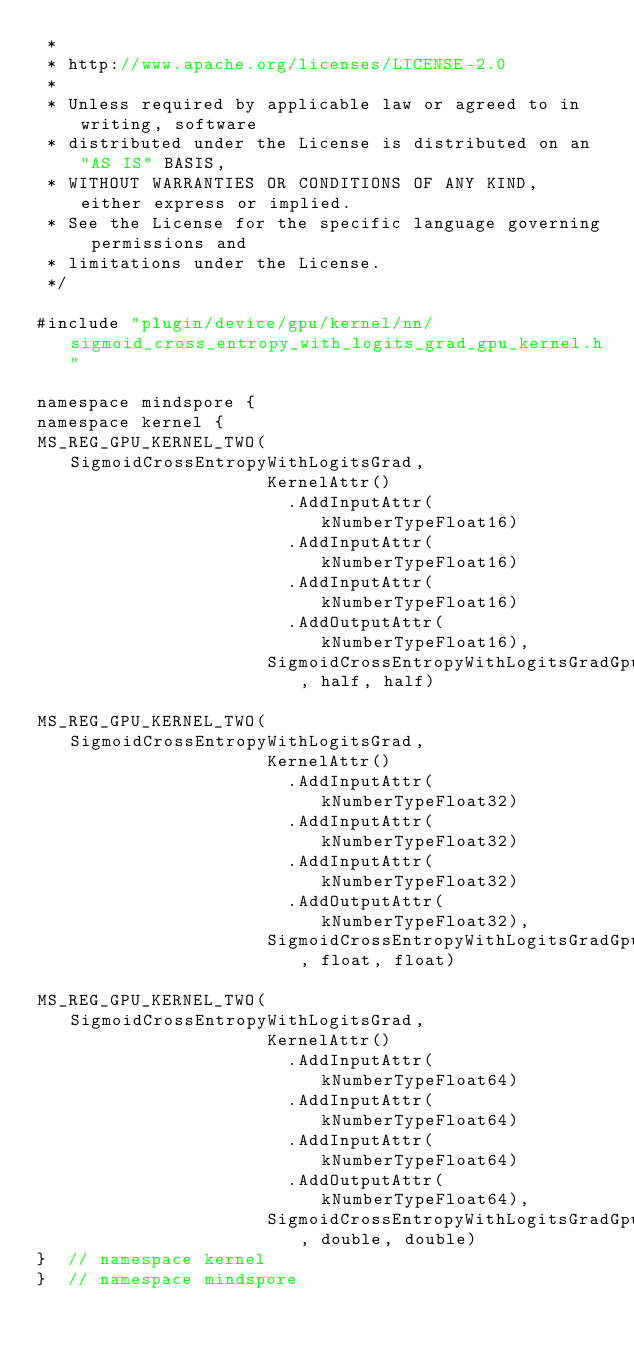<code> <loc_0><loc_0><loc_500><loc_500><_C++_> *
 * http://www.apache.org/licenses/LICENSE-2.0
 *
 * Unless required by applicable law or agreed to in writing, software
 * distributed under the License is distributed on an "AS IS" BASIS,
 * WITHOUT WARRANTIES OR CONDITIONS OF ANY KIND, either express or implied.
 * See the License for the specific language governing permissions and
 * limitations under the License.
 */

#include "plugin/device/gpu/kernel/nn/sigmoid_cross_entropy_with_logits_grad_gpu_kernel.h"

namespace mindspore {
namespace kernel {
MS_REG_GPU_KERNEL_TWO(SigmoidCrossEntropyWithLogitsGrad,
                      KernelAttr()
                        .AddInputAttr(kNumberTypeFloat16)
                        .AddInputAttr(kNumberTypeFloat16)
                        .AddInputAttr(kNumberTypeFloat16)
                        .AddOutputAttr(kNumberTypeFloat16),
                      SigmoidCrossEntropyWithLogitsGradGpuKernelMod, half, half)

MS_REG_GPU_KERNEL_TWO(SigmoidCrossEntropyWithLogitsGrad,
                      KernelAttr()
                        .AddInputAttr(kNumberTypeFloat32)
                        .AddInputAttr(kNumberTypeFloat32)
                        .AddInputAttr(kNumberTypeFloat32)
                        .AddOutputAttr(kNumberTypeFloat32),
                      SigmoidCrossEntropyWithLogitsGradGpuKernelMod, float, float)

MS_REG_GPU_KERNEL_TWO(SigmoidCrossEntropyWithLogitsGrad,
                      KernelAttr()
                        .AddInputAttr(kNumberTypeFloat64)
                        .AddInputAttr(kNumberTypeFloat64)
                        .AddInputAttr(kNumberTypeFloat64)
                        .AddOutputAttr(kNumberTypeFloat64),
                      SigmoidCrossEntropyWithLogitsGradGpuKernelMod, double, double)
}  // namespace kernel
}  // namespace mindspore
</code> 